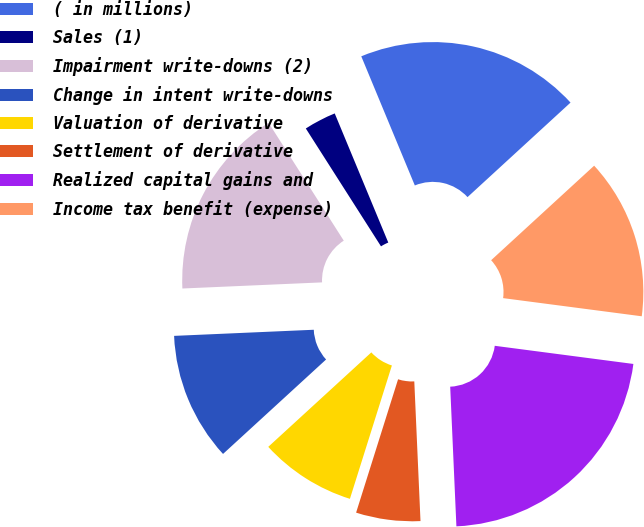<chart> <loc_0><loc_0><loc_500><loc_500><pie_chart><fcel>( in millions)<fcel>Sales (1)<fcel>Impairment write-downs (2)<fcel>Change in intent write-downs<fcel>Valuation of derivative<fcel>Settlement of derivative<fcel>Realized capital gains and<fcel>Income tax benefit (expense)<nl><fcel>19.44%<fcel>2.78%<fcel>16.66%<fcel>11.11%<fcel>8.34%<fcel>5.56%<fcel>22.22%<fcel>13.89%<nl></chart> 